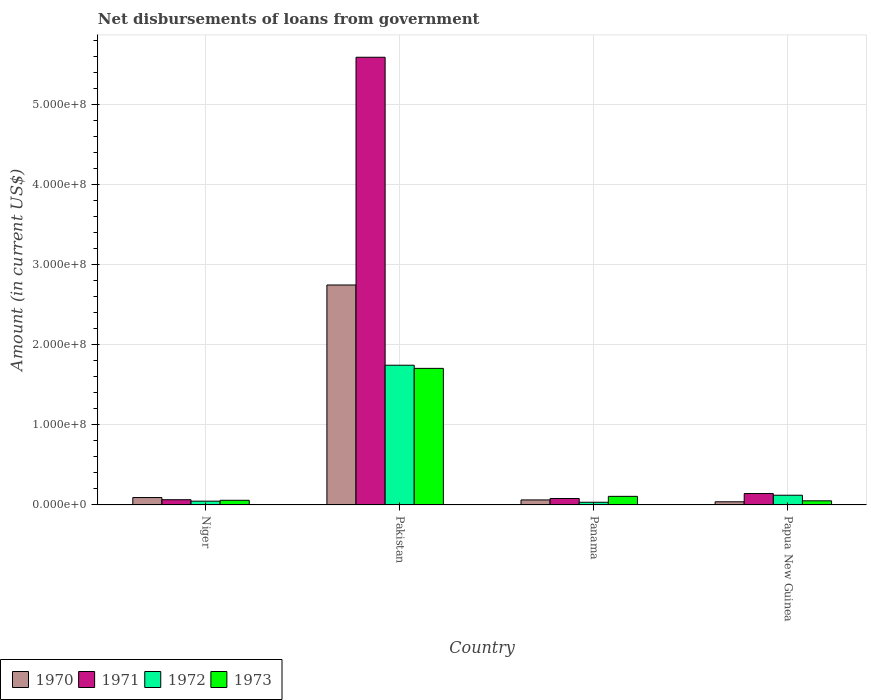How many different coloured bars are there?
Give a very brief answer. 4. Are the number of bars per tick equal to the number of legend labels?
Provide a succinct answer. Yes. How many bars are there on the 2nd tick from the left?
Offer a terse response. 4. In how many cases, is the number of bars for a given country not equal to the number of legend labels?
Give a very brief answer. 0. What is the amount of loan disbursed from government in 1970 in Niger?
Make the answer very short. 9.21e+06. Across all countries, what is the maximum amount of loan disbursed from government in 1973?
Keep it short and to the point. 1.70e+08. Across all countries, what is the minimum amount of loan disbursed from government in 1971?
Your answer should be compact. 6.50e+06. In which country was the amount of loan disbursed from government in 1973 minimum?
Offer a terse response. Papua New Guinea. What is the total amount of loan disbursed from government in 1973 in the graph?
Ensure brevity in your answer.  1.92e+08. What is the difference between the amount of loan disbursed from government in 1971 in Pakistan and that in Panama?
Ensure brevity in your answer.  5.51e+08. What is the difference between the amount of loan disbursed from government in 1970 in Panama and the amount of loan disbursed from government in 1972 in Papua New Guinea?
Your answer should be compact. -5.86e+06. What is the average amount of loan disbursed from government in 1973 per country?
Ensure brevity in your answer.  4.80e+07. What is the difference between the amount of loan disbursed from government of/in 1971 and amount of loan disbursed from government of/in 1973 in Papua New Guinea?
Offer a very short reply. 9.06e+06. What is the ratio of the amount of loan disbursed from government in 1972 in Pakistan to that in Panama?
Offer a terse response. 52.11. Is the amount of loan disbursed from government in 1972 in Pakistan less than that in Papua New Guinea?
Provide a succinct answer. No. Is the difference between the amount of loan disbursed from government in 1971 in Niger and Papua New Guinea greater than the difference between the amount of loan disbursed from government in 1973 in Niger and Papua New Guinea?
Make the answer very short. No. What is the difference between the highest and the second highest amount of loan disbursed from government in 1970?
Offer a terse response. 2.68e+08. What is the difference between the highest and the lowest amount of loan disbursed from government in 1972?
Your answer should be very brief. 1.71e+08. Is the sum of the amount of loan disbursed from government in 1970 in Pakistan and Panama greater than the maximum amount of loan disbursed from government in 1971 across all countries?
Your answer should be very brief. No. Is it the case that in every country, the sum of the amount of loan disbursed from government in 1970 and amount of loan disbursed from government in 1971 is greater than the sum of amount of loan disbursed from government in 1973 and amount of loan disbursed from government in 1972?
Your answer should be compact. Yes. Is it the case that in every country, the sum of the amount of loan disbursed from government in 1973 and amount of loan disbursed from government in 1972 is greater than the amount of loan disbursed from government in 1971?
Keep it short and to the point. No. How many bars are there?
Your answer should be very brief. 16. What is the difference between two consecutive major ticks on the Y-axis?
Give a very brief answer. 1.00e+08. Does the graph contain grids?
Provide a short and direct response. Yes. What is the title of the graph?
Provide a short and direct response. Net disbursements of loans from government. Does "1966" appear as one of the legend labels in the graph?
Make the answer very short. No. What is the Amount (in current US$) of 1970 in Niger?
Your response must be concise. 9.21e+06. What is the Amount (in current US$) in 1971 in Niger?
Offer a very short reply. 6.50e+06. What is the Amount (in current US$) in 1972 in Niger?
Your response must be concise. 4.70e+06. What is the Amount (in current US$) in 1973 in Niger?
Ensure brevity in your answer.  5.79e+06. What is the Amount (in current US$) in 1970 in Pakistan?
Offer a very short reply. 2.74e+08. What is the Amount (in current US$) of 1971 in Pakistan?
Ensure brevity in your answer.  5.59e+08. What is the Amount (in current US$) in 1972 in Pakistan?
Provide a short and direct response. 1.74e+08. What is the Amount (in current US$) in 1973 in Pakistan?
Make the answer very short. 1.70e+08. What is the Amount (in current US$) of 1970 in Panama?
Your answer should be very brief. 6.24e+06. What is the Amount (in current US$) in 1971 in Panama?
Ensure brevity in your answer.  8.01e+06. What is the Amount (in current US$) in 1972 in Panama?
Provide a short and direct response. 3.34e+06. What is the Amount (in current US$) of 1973 in Panama?
Provide a short and direct response. 1.07e+07. What is the Amount (in current US$) in 1970 in Papua New Guinea?
Your answer should be very brief. 3.92e+06. What is the Amount (in current US$) of 1971 in Papua New Guinea?
Make the answer very short. 1.42e+07. What is the Amount (in current US$) of 1972 in Papua New Guinea?
Ensure brevity in your answer.  1.21e+07. What is the Amount (in current US$) in 1973 in Papua New Guinea?
Offer a very short reply. 5.14e+06. Across all countries, what is the maximum Amount (in current US$) of 1970?
Keep it short and to the point. 2.74e+08. Across all countries, what is the maximum Amount (in current US$) of 1971?
Your answer should be compact. 5.59e+08. Across all countries, what is the maximum Amount (in current US$) of 1972?
Ensure brevity in your answer.  1.74e+08. Across all countries, what is the maximum Amount (in current US$) of 1973?
Give a very brief answer. 1.70e+08. Across all countries, what is the minimum Amount (in current US$) of 1970?
Keep it short and to the point. 3.92e+06. Across all countries, what is the minimum Amount (in current US$) in 1971?
Ensure brevity in your answer.  6.50e+06. Across all countries, what is the minimum Amount (in current US$) of 1972?
Keep it short and to the point. 3.34e+06. Across all countries, what is the minimum Amount (in current US$) in 1973?
Your answer should be compact. 5.14e+06. What is the total Amount (in current US$) of 1970 in the graph?
Make the answer very short. 2.94e+08. What is the total Amount (in current US$) of 1971 in the graph?
Give a very brief answer. 5.87e+08. What is the total Amount (in current US$) of 1972 in the graph?
Offer a terse response. 1.94e+08. What is the total Amount (in current US$) in 1973 in the graph?
Ensure brevity in your answer.  1.92e+08. What is the difference between the Amount (in current US$) of 1970 in Niger and that in Pakistan?
Offer a terse response. -2.65e+08. What is the difference between the Amount (in current US$) of 1971 in Niger and that in Pakistan?
Your answer should be compact. -5.52e+08. What is the difference between the Amount (in current US$) in 1972 in Niger and that in Pakistan?
Offer a very short reply. -1.70e+08. What is the difference between the Amount (in current US$) in 1973 in Niger and that in Pakistan?
Make the answer very short. -1.65e+08. What is the difference between the Amount (in current US$) in 1970 in Niger and that in Panama?
Make the answer very short. 2.96e+06. What is the difference between the Amount (in current US$) in 1971 in Niger and that in Panama?
Your response must be concise. -1.51e+06. What is the difference between the Amount (in current US$) of 1972 in Niger and that in Panama?
Give a very brief answer. 1.36e+06. What is the difference between the Amount (in current US$) in 1973 in Niger and that in Panama?
Your answer should be very brief. -4.91e+06. What is the difference between the Amount (in current US$) in 1970 in Niger and that in Papua New Guinea?
Offer a very short reply. 5.29e+06. What is the difference between the Amount (in current US$) of 1971 in Niger and that in Papua New Guinea?
Keep it short and to the point. -7.70e+06. What is the difference between the Amount (in current US$) in 1972 in Niger and that in Papua New Guinea?
Provide a succinct answer. -7.40e+06. What is the difference between the Amount (in current US$) in 1973 in Niger and that in Papua New Guinea?
Ensure brevity in your answer.  6.53e+05. What is the difference between the Amount (in current US$) in 1970 in Pakistan and that in Panama?
Your response must be concise. 2.68e+08. What is the difference between the Amount (in current US$) in 1971 in Pakistan and that in Panama?
Make the answer very short. 5.51e+08. What is the difference between the Amount (in current US$) of 1972 in Pakistan and that in Panama?
Your answer should be very brief. 1.71e+08. What is the difference between the Amount (in current US$) of 1973 in Pakistan and that in Panama?
Your response must be concise. 1.60e+08. What is the difference between the Amount (in current US$) of 1970 in Pakistan and that in Papua New Guinea?
Ensure brevity in your answer.  2.70e+08. What is the difference between the Amount (in current US$) in 1971 in Pakistan and that in Papua New Guinea?
Give a very brief answer. 5.44e+08. What is the difference between the Amount (in current US$) in 1972 in Pakistan and that in Papua New Guinea?
Provide a short and direct response. 1.62e+08. What is the difference between the Amount (in current US$) of 1973 in Pakistan and that in Papua New Guinea?
Keep it short and to the point. 1.65e+08. What is the difference between the Amount (in current US$) of 1970 in Panama and that in Papua New Guinea?
Make the answer very short. 2.32e+06. What is the difference between the Amount (in current US$) in 1971 in Panama and that in Papua New Guinea?
Your response must be concise. -6.19e+06. What is the difference between the Amount (in current US$) of 1972 in Panama and that in Papua New Guinea?
Your response must be concise. -8.76e+06. What is the difference between the Amount (in current US$) of 1973 in Panama and that in Papua New Guinea?
Provide a succinct answer. 5.56e+06. What is the difference between the Amount (in current US$) of 1970 in Niger and the Amount (in current US$) of 1971 in Pakistan?
Your answer should be very brief. -5.49e+08. What is the difference between the Amount (in current US$) of 1970 in Niger and the Amount (in current US$) of 1972 in Pakistan?
Offer a terse response. -1.65e+08. What is the difference between the Amount (in current US$) in 1970 in Niger and the Amount (in current US$) in 1973 in Pakistan?
Provide a succinct answer. -1.61e+08. What is the difference between the Amount (in current US$) in 1971 in Niger and the Amount (in current US$) in 1972 in Pakistan?
Make the answer very short. -1.68e+08. What is the difference between the Amount (in current US$) in 1971 in Niger and the Amount (in current US$) in 1973 in Pakistan?
Make the answer very short. -1.64e+08. What is the difference between the Amount (in current US$) in 1972 in Niger and the Amount (in current US$) in 1973 in Pakistan?
Give a very brief answer. -1.66e+08. What is the difference between the Amount (in current US$) in 1970 in Niger and the Amount (in current US$) in 1971 in Panama?
Offer a terse response. 1.20e+06. What is the difference between the Amount (in current US$) of 1970 in Niger and the Amount (in current US$) of 1972 in Panama?
Ensure brevity in your answer.  5.86e+06. What is the difference between the Amount (in current US$) of 1970 in Niger and the Amount (in current US$) of 1973 in Panama?
Your answer should be compact. -1.50e+06. What is the difference between the Amount (in current US$) of 1971 in Niger and the Amount (in current US$) of 1972 in Panama?
Your response must be concise. 3.15e+06. What is the difference between the Amount (in current US$) in 1971 in Niger and the Amount (in current US$) in 1973 in Panama?
Make the answer very short. -4.21e+06. What is the difference between the Amount (in current US$) in 1972 in Niger and the Amount (in current US$) in 1973 in Panama?
Provide a succinct answer. -6.00e+06. What is the difference between the Amount (in current US$) of 1970 in Niger and the Amount (in current US$) of 1971 in Papua New Guinea?
Provide a short and direct response. -4.99e+06. What is the difference between the Amount (in current US$) in 1970 in Niger and the Amount (in current US$) in 1972 in Papua New Guinea?
Provide a short and direct response. -2.90e+06. What is the difference between the Amount (in current US$) in 1970 in Niger and the Amount (in current US$) in 1973 in Papua New Guinea?
Your answer should be very brief. 4.07e+06. What is the difference between the Amount (in current US$) in 1971 in Niger and the Amount (in current US$) in 1972 in Papua New Guinea?
Keep it short and to the point. -5.61e+06. What is the difference between the Amount (in current US$) in 1971 in Niger and the Amount (in current US$) in 1973 in Papua New Guinea?
Give a very brief answer. 1.36e+06. What is the difference between the Amount (in current US$) in 1972 in Niger and the Amount (in current US$) in 1973 in Papua New Guinea?
Offer a terse response. -4.35e+05. What is the difference between the Amount (in current US$) in 1970 in Pakistan and the Amount (in current US$) in 1971 in Panama?
Offer a very short reply. 2.66e+08. What is the difference between the Amount (in current US$) of 1970 in Pakistan and the Amount (in current US$) of 1972 in Panama?
Provide a succinct answer. 2.71e+08. What is the difference between the Amount (in current US$) in 1970 in Pakistan and the Amount (in current US$) in 1973 in Panama?
Ensure brevity in your answer.  2.64e+08. What is the difference between the Amount (in current US$) in 1971 in Pakistan and the Amount (in current US$) in 1972 in Panama?
Your response must be concise. 5.55e+08. What is the difference between the Amount (in current US$) of 1971 in Pakistan and the Amount (in current US$) of 1973 in Panama?
Your response must be concise. 5.48e+08. What is the difference between the Amount (in current US$) of 1972 in Pakistan and the Amount (in current US$) of 1973 in Panama?
Ensure brevity in your answer.  1.64e+08. What is the difference between the Amount (in current US$) of 1970 in Pakistan and the Amount (in current US$) of 1971 in Papua New Guinea?
Offer a terse response. 2.60e+08. What is the difference between the Amount (in current US$) in 1970 in Pakistan and the Amount (in current US$) in 1972 in Papua New Guinea?
Give a very brief answer. 2.62e+08. What is the difference between the Amount (in current US$) of 1970 in Pakistan and the Amount (in current US$) of 1973 in Papua New Guinea?
Offer a terse response. 2.69e+08. What is the difference between the Amount (in current US$) in 1971 in Pakistan and the Amount (in current US$) in 1972 in Papua New Guinea?
Make the answer very short. 5.46e+08. What is the difference between the Amount (in current US$) of 1971 in Pakistan and the Amount (in current US$) of 1973 in Papua New Guinea?
Give a very brief answer. 5.53e+08. What is the difference between the Amount (in current US$) in 1972 in Pakistan and the Amount (in current US$) in 1973 in Papua New Guinea?
Your answer should be very brief. 1.69e+08. What is the difference between the Amount (in current US$) of 1970 in Panama and the Amount (in current US$) of 1971 in Papua New Guinea?
Your response must be concise. -7.96e+06. What is the difference between the Amount (in current US$) in 1970 in Panama and the Amount (in current US$) in 1972 in Papua New Guinea?
Offer a very short reply. -5.86e+06. What is the difference between the Amount (in current US$) in 1970 in Panama and the Amount (in current US$) in 1973 in Papua New Guinea?
Your answer should be compact. 1.10e+06. What is the difference between the Amount (in current US$) of 1971 in Panama and the Amount (in current US$) of 1972 in Papua New Guinea?
Give a very brief answer. -4.09e+06. What is the difference between the Amount (in current US$) of 1971 in Panama and the Amount (in current US$) of 1973 in Papua New Guinea?
Provide a short and direct response. 2.87e+06. What is the difference between the Amount (in current US$) of 1972 in Panama and the Amount (in current US$) of 1973 in Papua New Guinea?
Your response must be concise. -1.79e+06. What is the average Amount (in current US$) of 1970 per country?
Keep it short and to the point. 7.34e+07. What is the average Amount (in current US$) in 1971 per country?
Make the answer very short. 1.47e+08. What is the average Amount (in current US$) in 1972 per country?
Offer a very short reply. 4.86e+07. What is the average Amount (in current US$) of 1973 per country?
Provide a succinct answer. 4.80e+07. What is the difference between the Amount (in current US$) in 1970 and Amount (in current US$) in 1971 in Niger?
Offer a very short reply. 2.71e+06. What is the difference between the Amount (in current US$) of 1970 and Amount (in current US$) of 1972 in Niger?
Give a very brief answer. 4.50e+06. What is the difference between the Amount (in current US$) in 1970 and Amount (in current US$) in 1973 in Niger?
Provide a succinct answer. 3.42e+06. What is the difference between the Amount (in current US$) of 1971 and Amount (in current US$) of 1972 in Niger?
Give a very brief answer. 1.79e+06. What is the difference between the Amount (in current US$) in 1971 and Amount (in current US$) in 1973 in Niger?
Give a very brief answer. 7.04e+05. What is the difference between the Amount (in current US$) of 1972 and Amount (in current US$) of 1973 in Niger?
Provide a succinct answer. -1.09e+06. What is the difference between the Amount (in current US$) of 1970 and Amount (in current US$) of 1971 in Pakistan?
Your response must be concise. -2.84e+08. What is the difference between the Amount (in current US$) in 1970 and Amount (in current US$) in 1972 in Pakistan?
Your answer should be very brief. 1.00e+08. What is the difference between the Amount (in current US$) in 1970 and Amount (in current US$) in 1973 in Pakistan?
Offer a very short reply. 1.04e+08. What is the difference between the Amount (in current US$) in 1971 and Amount (in current US$) in 1972 in Pakistan?
Your answer should be very brief. 3.84e+08. What is the difference between the Amount (in current US$) in 1971 and Amount (in current US$) in 1973 in Pakistan?
Give a very brief answer. 3.88e+08. What is the difference between the Amount (in current US$) of 1972 and Amount (in current US$) of 1973 in Pakistan?
Your answer should be very brief. 3.90e+06. What is the difference between the Amount (in current US$) of 1970 and Amount (in current US$) of 1971 in Panama?
Provide a succinct answer. -1.77e+06. What is the difference between the Amount (in current US$) in 1970 and Amount (in current US$) in 1972 in Panama?
Offer a terse response. 2.90e+06. What is the difference between the Amount (in current US$) of 1970 and Amount (in current US$) of 1973 in Panama?
Your answer should be compact. -4.46e+06. What is the difference between the Amount (in current US$) of 1971 and Amount (in current US$) of 1972 in Panama?
Ensure brevity in your answer.  4.66e+06. What is the difference between the Amount (in current US$) in 1971 and Amount (in current US$) in 1973 in Panama?
Ensure brevity in your answer.  -2.69e+06. What is the difference between the Amount (in current US$) in 1972 and Amount (in current US$) in 1973 in Panama?
Make the answer very short. -7.36e+06. What is the difference between the Amount (in current US$) of 1970 and Amount (in current US$) of 1971 in Papua New Guinea?
Your answer should be very brief. -1.03e+07. What is the difference between the Amount (in current US$) of 1970 and Amount (in current US$) of 1972 in Papua New Guinea?
Your answer should be very brief. -8.18e+06. What is the difference between the Amount (in current US$) in 1970 and Amount (in current US$) in 1973 in Papua New Guinea?
Your answer should be very brief. -1.22e+06. What is the difference between the Amount (in current US$) in 1971 and Amount (in current US$) in 1972 in Papua New Guinea?
Keep it short and to the point. 2.10e+06. What is the difference between the Amount (in current US$) in 1971 and Amount (in current US$) in 1973 in Papua New Guinea?
Ensure brevity in your answer.  9.06e+06. What is the difference between the Amount (in current US$) of 1972 and Amount (in current US$) of 1973 in Papua New Guinea?
Your response must be concise. 6.96e+06. What is the ratio of the Amount (in current US$) of 1970 in Niger to that in Pakistan?
Ensure brevity in your answer.  0.03. What is the ratio of the Amount (in current US$) in 1971 in Niger to that in Pakistan?
Offer a terse response. 0.01. What is the ratio of the Amount (in current US$) of 1972 in Niger to that in Pakistan?
Ensure brevity in your answer.  0.03. What is the ratio of the Amount (in current US$) of 1973 in Niger to that in Pakistan?
Offer a very short reply. 0.03. What is the ratio of the Amount (in current US$) of 1970 in Niger to that in Panama?
Offer a terse response. 1.48. What is the ratio of the Amount (in current US$) in 1971 in Niger to that in Panama?
Offer a terse response. 0.81. What is the ratio of the Amount (in current US$) of 1972 in Niger to that in Panama?
Give a very brief answer. 1.41. What is the ratio of the Amount (in current US$) in 1973 in Niger to that in Panama?
Your answer should be compact. 0.54. What is the ratio of the Amount (in current US$) of 1970 in Niger to that in Papua New Guinea?
Give a very brief answer. 2.35. What is the ratio of the Amount (in current US$) in 1971 in Niger to that in Papua New Guinea?
Offer a very short reply. 0.46. What is the ratio of the Amount (in current US$) in 1972 in Niger to that in Papua New Guinea?
Offer a terse response. 0.39. What is the ratio of the Amount (in current US$) of 1973 in Niger to that in Papua New Guinea?
Your answer should be compact. 1.13. What is the ratio of the Amount (in current US$) in 1970 in Pakistan to that in Panama?
Offer a very short reply. 43.96. What is the ratio of the Amount (in current US$) of 1971 in Pakistan to that in Panama?
Make the answer very short. 69.73. What is the ratio of the Amount (in current US$) in 1972 in Pakistan to that in Panama?
Make the answer very short. 52.11. What is the ratio of the Amount (in current US$) in 1973 in Pakistan to that in Panama?
Offer a very short reply. 15.92. What is the ratio of the Amount (in current US$) in 1970 in Pakistan to that in Papua New Guinea?
Your answer should be very brief. 70. What is the ratio of the Amount (in current US$) of 1971 in Pakistan to that in Papua New Guinea?
Provide a short and direct response. 39.34. What is the ratio of the Amount (in current US$) of 1973 in Pakistan to that in Papua New Guinea?
Make the answer very short. 33.16. What is the ratio of the Amount (in current US$) of 1970 in Panama to that in Papua New Guinea?
Ensure brevity in your answer.  1.59. What is the ratio of the Amount (in current US$) in 1971 in Panama to that in Papua New Guinea?
Provide a short and direct response. 0.56. What is the ratio of the Amount (in current US$) in 1972 in Panama to that in Papua New Guinea?
Keep it short and to the point. 0.28. What is the ratio of the Amount (in current US$) of 1973 in Panama to that in Papua New Guinea?
Give a very brief answer. 2.08. What is the difference between the highest and the second highest Amount (in current US$) of 1970?
Make the answer very short. 2.65e+08. What is the difference between the highest and the second highest Amount (in current US$) in 1971?
Offer a very short reply. 5.44e+08. What is the difference between the highest and the second highest Amount (in current US$) of 1972?
Offer a terse response. 1.62e+08. What is the difference between the highest and the second highest Amount (in current US$) of 1973?
Provide a short and direct response. 1.60e+08. What is the difference between the highest and the lowest Amount (in current US$) of 1970?
Your response must be concise. 2.70e+08. What is the difference between the highest and the lowest Amount (in current US$) of 1971?
Offer a terse response. 5.52e+08. What is the difference between the highest and the lowest Amount (in current US$) of 1972?
Keep it short and to the point. 1.71e+08. What is the difference between the highest and the lowest Amount (in current US$) of 1973?
Offer a terse response. 1.65e+08. 